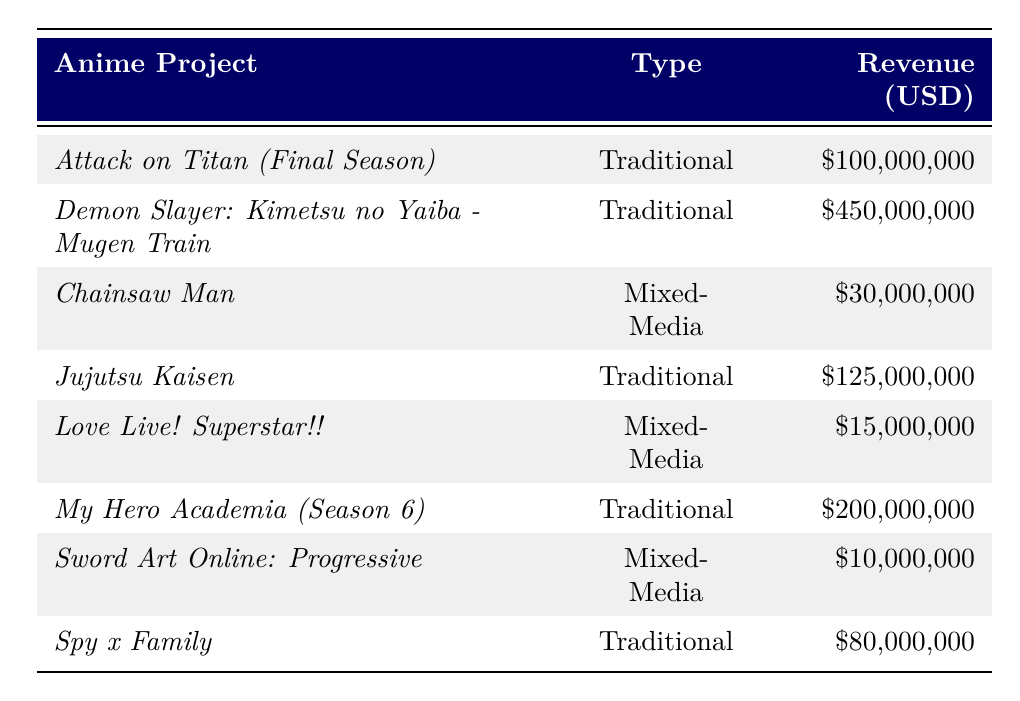What is the total revenue generated by traditional anime projects in 2022? Adding the revenues of all traditional anime projects: $100,000,000 (Attack on Titan) + $450,000,000 (Demon Slayer) + $125,000,000 (Jujutsu Kaisen) + $200,000,000 (My Hero Academia) + $80,000,000 (Spy x Family) = $955,000,000
Answer: $955,000,000 Which mixed-media project generated the highest revenue in 2022? Reviewing the table, the projects listed are Chainsaw Man ($30,000,000), Love Live! Superstar!! ($15,000,000), and Sword Art Online: Progressive ($10,000,000). Chainsaw Man has the highest revenue at $30,000,000.
Answer: Chainsaw Man What percentage of the total revenue do mixed-media projects represent compared to traditional anime projects? First, calculate the total revenue from mixed-media projects: $30,000,000 (Chainsaw Man) + $15,000,000 (Love Live! Superstar!!) + $10,000,000 (Sword Art Online) = $55,000,000. Then, calculate the percentage of this compared to traditional projects: ($55,000,000 / $955,000,000) * 100 ≈ 5.77%.
Answer: Approximately 5.77% Did any mixed-media projects surpass the revenue of the lowest traditional anime project? The lowest traditional anime project is Spy x Family with $80,000,000. The highest revenue for a mixed-media project is Chainsaw Man with $30,000,000, which is less than $80,000,000. Therefore, no mixed-media products surpassed it.
Answer: No If the total revenue of traditional anime projects is $955,000,000, how much more revenue did they generate than mixed-media projects? The total revenue of mixed-media projects is $55,000,000. The difference in revenue is $955,000,000 - $55,000,000 = $900,000,000.
Answer: $900,000,000 What is the average revenue of the mixed-media projects listed? Calculate the average by summing the revenues of mixed-media projects: $30,000,000 + $15,000,000 + $10,000,000 = $55,000,000. Then divide by the number of mixed-media projects (3): $55,000,000 / 3 ≈ $18,333,333.33.
Answer: Approximately $18,333,333.33 Which traditional anime project had the second highest revenue? Listing the revenues of traditional anime projects in order: Demon Slayer ($450,000,000), My Hero Academia ($200,000,000), Jujutsu Kaisen ($125,000,000), Attack on Titan ($100,000,000), and Spy x Family ($80,000,000). The second highest is My Hero Academia at $200,000,000.
Answer: My Hero Academia What is the difference in revenue between the highest and lowest revenue projects overall? The highest revenue project is Demon Slayer with $450,000,000, and the lowest is Sword Art Online with $10,000,000. The difference is $450,000,000 - $10,000,000 = $440,000,000.
Answer: $440,000,000 